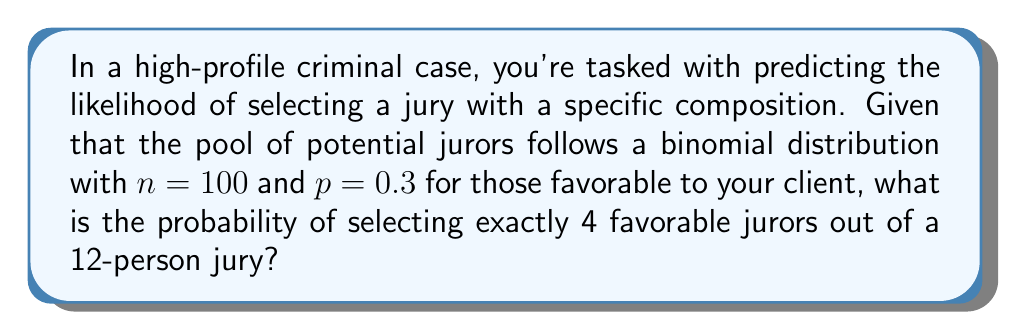Could you help me with this problem? To solve this problem, we'll use the hypergeometric distribution, which is appropriate for selection without replacement from a finite population.

Step 1: Identify the parameters for the hypergeometric distribution:
- $N$ = total population size = 100
- $K$ = number of successes in the population = $100 \cdot 0.3 = 30$ (favorable jurors)
- $n$ = number of draws = 12 (jury size)
- $k$ = number of successes in the sample = 4 (favorable jurors we want to select)

Step 2: Apply the hypergeometric probability mass function:

$$P(X=k) = \frac{\binom{K}{k}\binom{N-K}{n-k}}{\binom{N}{n}}$$

Step 3: Calculate the binomial coefficients:
- $\binom{30}{4} = 27405$
- $\binom{70}{8} = 586353480$
- $\binom{100}{12} = 17945268450$

Step 4: Substitute the values into the formula:

$$P(X=4) = \frac{27405 \cdot 586353480}{17945268450} \approx 0.0896$$

Step 5: Convert to a percentage:
0.0896 * 100 ≈ 8.96%
Answer: 8.96% 